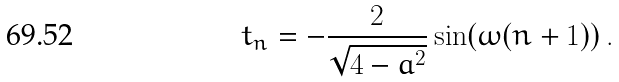<formula> <loc_0><loc_0><loc_500><loc_500>t _ { n } = - \frac { 2 } { \sqrt { 4 - a ^ { 2 } } } \sin ( \omega ( n + 1 ) ) \, .</formula> 